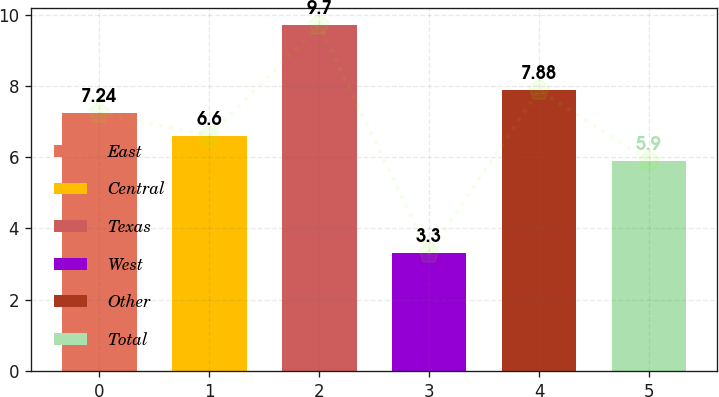<chart> <loc_0><loc_0><loc_500><loc_500><bar_chart><fcel>East<fcel>Central<fcel>Texas<fcel>West<fcel>Other<fcel>Total<nl><fcel>7.24<fcel>6.6<fcel>9.7<fcel>3.3<fcel>7.88<fcel>5.9<nl></chart> 